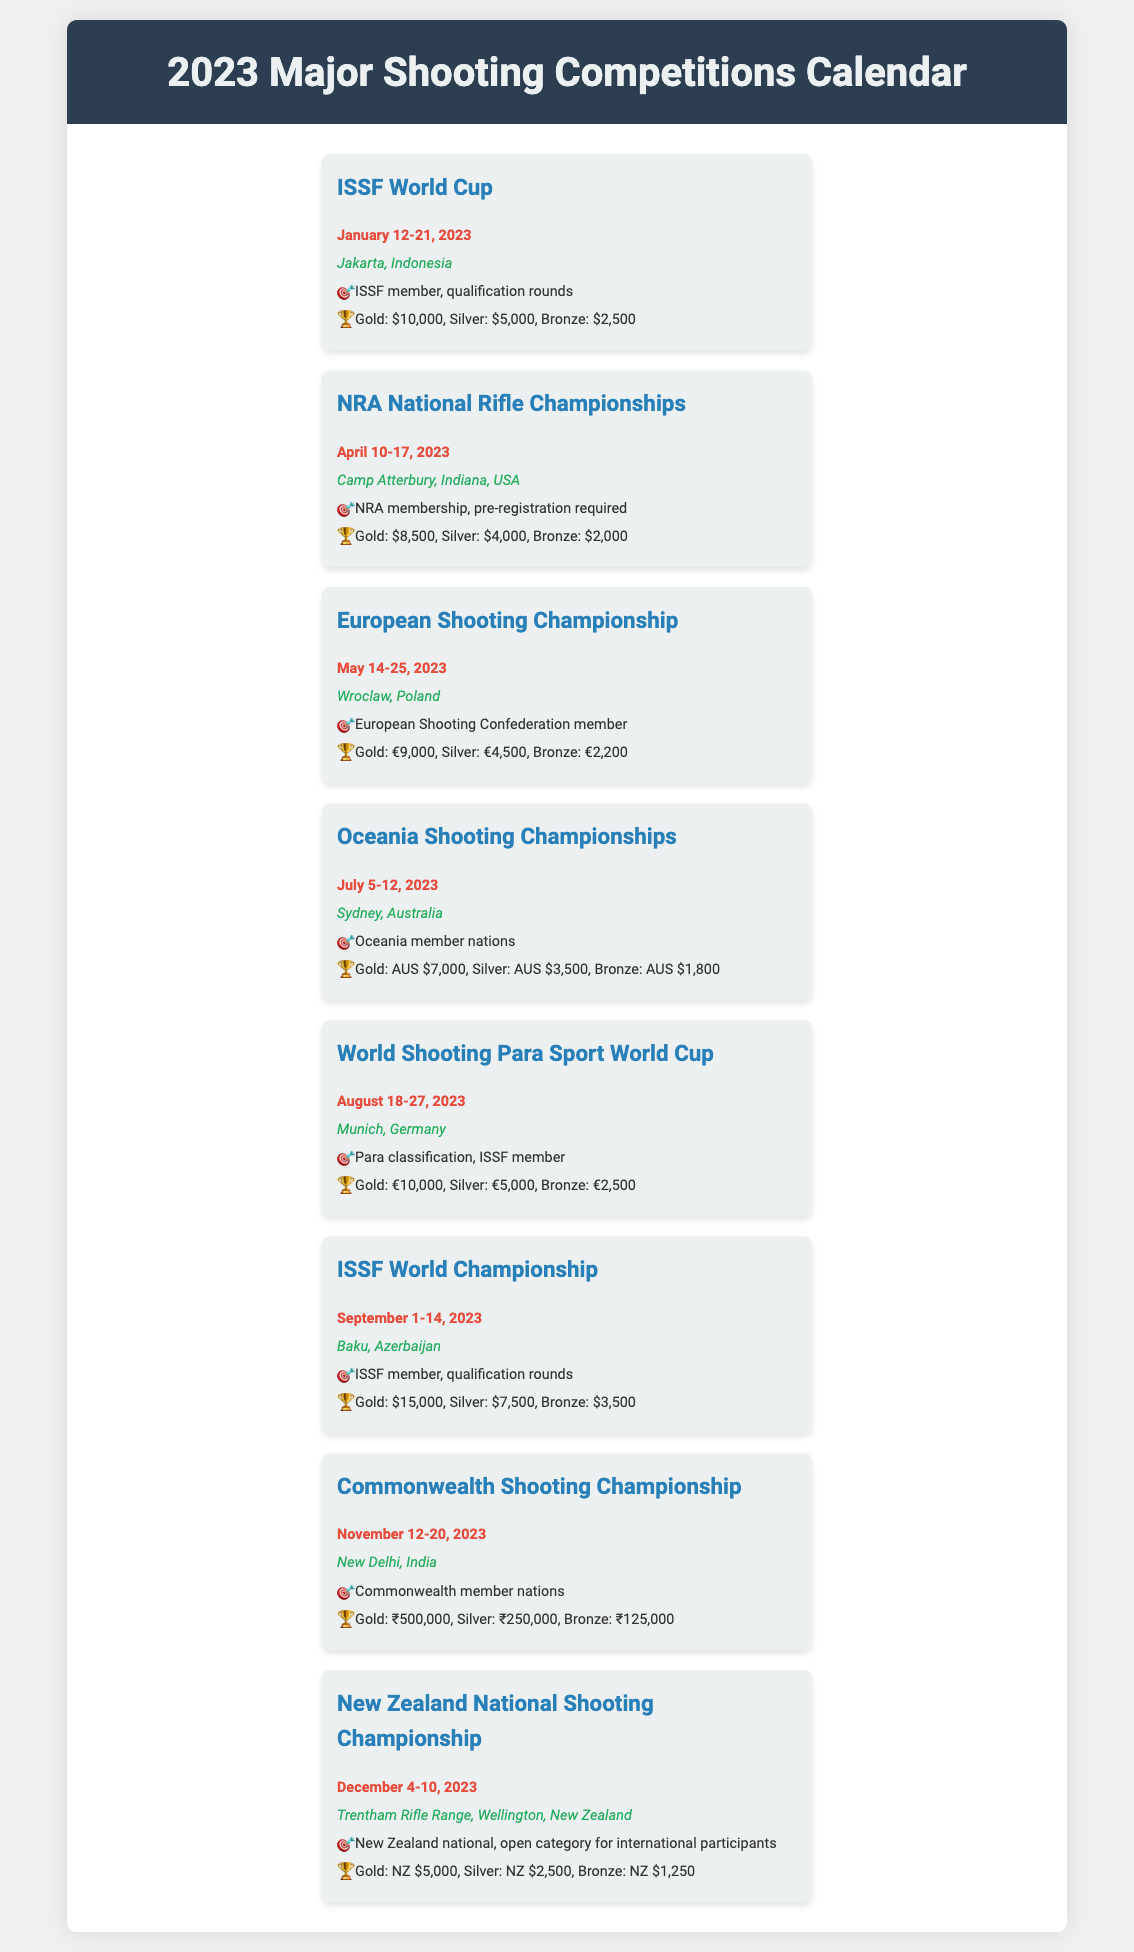What is the date of the ISSF World Cup? The document lists the date for the ISSF World Cup as January 12-21, 2023.
Answer: January 12-21, 2023 Where is the NRA National Rifle Championships held? The document specifies that the NRA National Rifle Championships takes place at Camp Atterbury, Indiana, USA.
Answer: Camp Atterbury, Indiana, USA What is the prize for Gold in the European Shooting Championship? According to the document, the Gold prize for the European Shooting Championship is €9,000.
Answer: €9,000 Which competition requires Para classification? The document indicates that the World Shooting Para Sport World Cup requires Para classification.
Answer: World Shooting Para Sport World Cup How many competitions are held in the month of May? The document provides details for two competitions in May, which are the European Shooting Championship.
Answer: 1 What is the location of the New Zealand National Shooting Championship? The document states that the New Zealand National Shooting Championship takes place at Trentham Rifle Range, Wellington, New Zealand.
Answer: Trentham Rifle Range, Wellington, New Zealand What membership is required for participating in the ISSF World Championship? The document notes that an ISSF member and qualification rounds are required for the ISSF World Championship.
Answer: ISSF member, qualification rounds Which competition has the highest Bronze prize money? The ISSF World Championship is mentioned in the document as having the highest Bronze prize of $3,500.
Answer: ISSF World Championship 